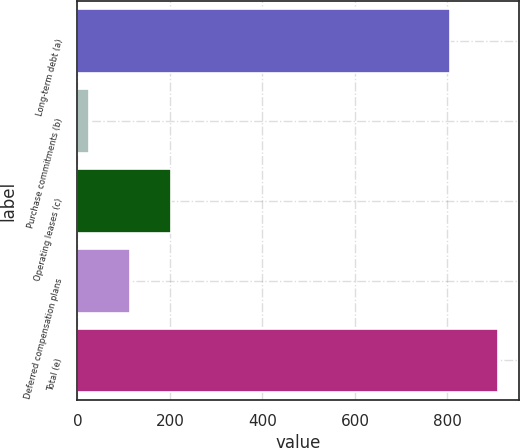Convert chart. <chart><loc_0><loc_0><loc_500><loc_500><bar_chart><fcel>Long-term debt (a)<fcel>Purchase commitments (b)<fcel>Operating leases (c)<fcel>Deferred compensation plans<fcel>Total (e)<nl><fcel>806<fcel>26<fcel>202.8<fcel>114.4<fcel>910<nl></chart> 